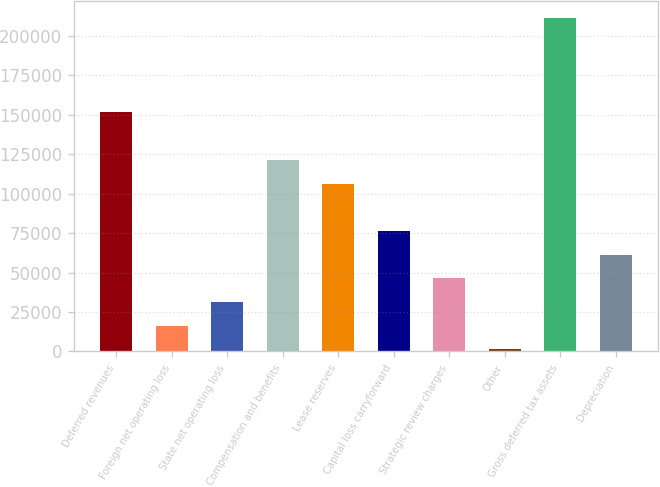<chart> <loc_0><loc_0><loc_500><loc_500><bar_chart><fcel>Deferred revenues<fcel>Foreign net operating loss<fcel>State net operating loss<fcel>Compensation and benefits<fcel>Lease reserves<fcel>Capital loss carryforward<fcel>Strategic review charges<fcel>Other<fcel>Gross deferred tax assets<fcel>Depreciation<nl><fcel>151438<fcel>16246.3<fcel>31267.6<fcel>121395<fcel>106374<fcel>76331.5<fcel>46288.9<fcel>1225<fcel>211523<fcel>61310.2<nl></chart> 